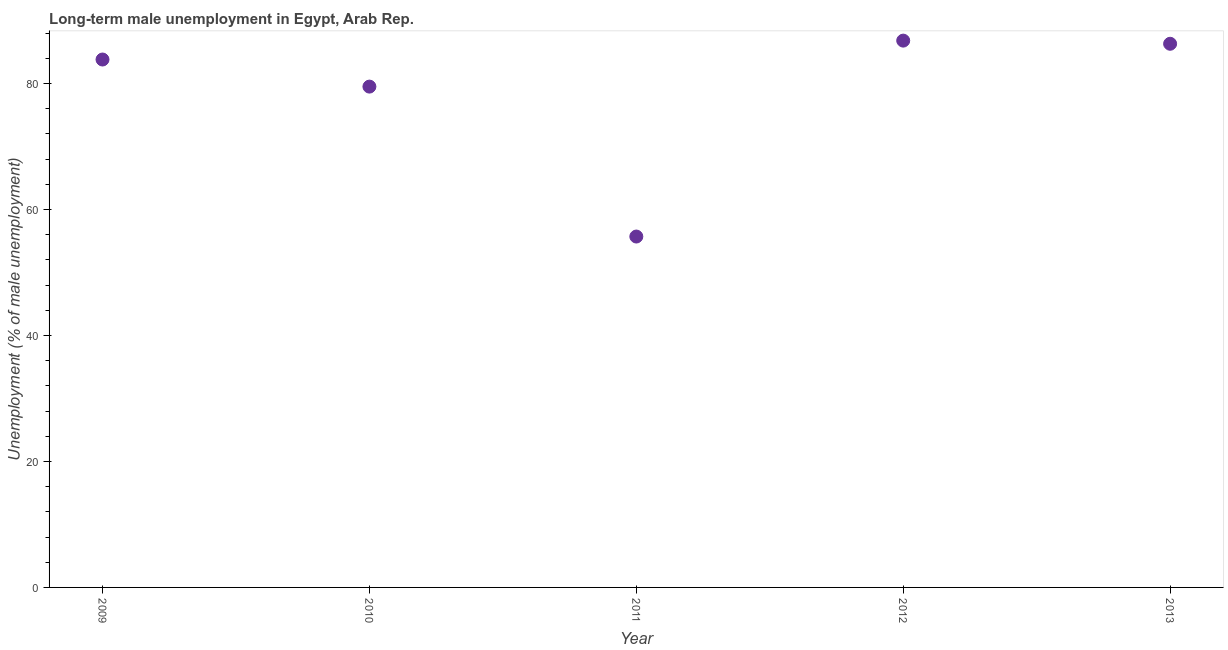What is the long-term male unemployment in 2011?
Your answer should be very brief. 55.7. Across all years, what is the maximum long-term male unemployment?
Ensure brevity in your answer.  86.8. Across all years, what is the minimum long-term male unemployment?
Provide a succinct answer. 55.7. In which year was the long-term male unemployment maximum?
Your answer should be very brief. 2012. In which year was the long-term male unemployment minimum?
Keep it short and to the point. 2011. What is the sum of the long-term male unemployment?
Keep it short and to the point. 392.1. What is the average long-term male unemployment per year?
Your answer should be compact. 78.42. What is the median long-term male unemployment?
Make the answer very short. 83.8. In how many years, is the long-term male unemployment greater than 4 %?
Ensure brevity in your answer.  5. Do a majority of the years between 2009 and 2010 (inclusive) have long-term male unemployment greater than 16 %?
Provide a short and direct response. Yes. What is the ratio of the long-term male unemployment in 2011 to that in 2012?
Give a very brief answer. 0.64. Is the long-term male unemployment in 2010 less than that in 2013?
Ensure brevity in your answer.  Yes. What is the difference between the highest and the second highest long-term male unemployment?
Offer a very short reply. 0.5. What is the difference between the highest and the lowest long-term male unemployment?
Keep it short and to the point. 31.1. In how many years, is the long-term male unemployment greater than the average long-term male unemployment taken over all years?
Make the answer very short. 4. Does the long-term male unemployment monotonically increase over the years?
Provide a succinct answer. No. How many dotlines are there?
Your response must be concise. 1. What is the difference between two consecutive major ticks on the Y-axis?
Provide a short and direct response. 20. Does the graph contain any zero values?
Provide a short and direct response. No. What is the title of the graph?
Provide a succinct answer. Long-term male unemployment in Egypt, Arab Rep. What is the label or title of the X-axis?
Your response must be concise. Year. What is the label or title of the Y-axis?
Ensure brevity in your answer.  Unemployment (% of male unemployment). What is the Unemployment (% of male unemployment) in 2009?
Provide a succinct answer. 83.8. What is the Unemployment (% of male unemployment) in 2010?
Your response must be concise. 79.5. What is the Unemployment (% of male unemployment) in 2011?
Give a very brief answer. 55.7. What is the Unemployment (% of male unemployment) in 2012?
Offer a very short reply. 86.8. What is the Unemployment (% of male unemployment) in 2013?
Offer a terse response. 86.3. What is the difference between the Unemployment (% of male unemployment) in 2009 and 2010?
Make the answer very short. 4.3. What is the difference between the Unemployment (% of male unemployment) in 2009 and 2011?
Provide a succinct answer. 28.1. What is the difference between the Unemployment (% of male unemployment) in 2009 and 2013?
Offer a terse response. -2.5. What is the difference between the Unemployment (% of male unemployment) in 2010 and 2011?
Make the answer very short. 23.8. What is the difference between the Unemployment (% of male unemployment) in 2010 and 2012?
Ensure brevity in your answer.  -7.3. What is the difference between the Unemployment (% of male unemployment) in 2011 and 2012?
Make the answer very short. -31.1. What is the difference between the Unemployment (% of male unemployment) in 2011 and 2013?
Your answer should be compact. -30.6. What is the ratio of the Unemployment (% of male unemployment) in 2009 to that in 2010?
Ensure brevity in your answer.  1.05. What is the ratio of the Unemployment (% of male unemployment) in 2009 to that in 2011?
Offer a terse response. 1.5. What is the ratio of the Unemployment (% of male unemployment) in 2009 to that in 2012?
Provide a short and direct response. 0.96. What is the ratio of the Unemployment (% of male unemployment) in 2010 to that in 2011?
Provide a short and direct response. 1.43. What is the ratio of the Unemployment (% of male unemployment) in 2010 to that in 2012?
Provide a succinct answer. 0.92. What is the ratio of the Unemployment (% of male unemployment) in 2010 to that in 2013?
Your answer should be compact. 0.92. What is the ratio of the Unemployment (% of male unemployment) in 2011 to that in 2012?
Offer a very short reply. 0.64. What is the ratio of the Unemployment (% of male unemployment) in 2011 to that in 2013?
Provide a succinct answer. 0.65. 